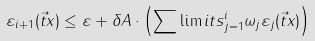<formula> <loc_0><loc_0><loc_500><loc_500>& \varepsilon _ { i + 1 } ( \vec { t } { x } ) \leq \varepsilon + \delta A \cdot \left ( \sum \lim i t s _ { j = 1 } ^ { i } \omega _ { j } \varepsilon _ { j } ( \vec { t } { x } ) \right )</formula> 